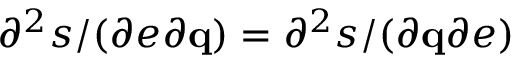Convert formula to latex. <formula><loc_0><loc_0><loc_500><loc_500>\partial ^ { 2 } s / ( \partial e \partial \mathbf q ) = \partial ^ { 2 } s / ( \partial \mathbf q \partial e )</formula> 